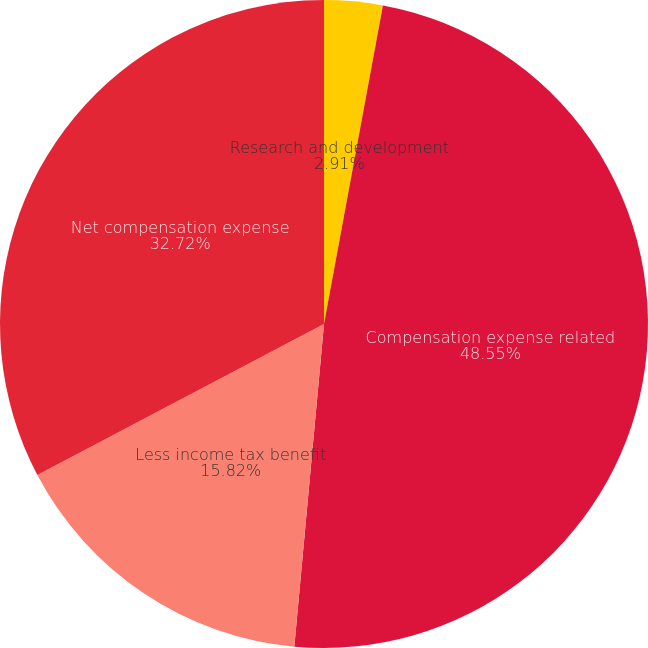Convert chart to OTSL. <chart><loc_0><loc_0><loc_500><loc_500><pie_chart><fcel>Research and development<fcel>Compensation expense related<fcel>Less income tax benefit<fcel>Net compensation expense<nl><fcel>2.91%<fcel>48.55%<fcel>15.82%<fcel>32.72%<nl></chart> 